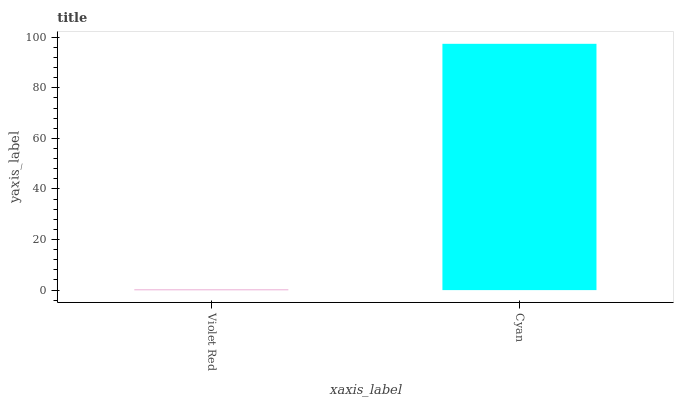Is Violet Red the minimum?
Answer yes or no. Yes. Is Cyan the maximum?
Answer yes or no. Yes. Is Cyan the minimum?
Answer yes or no. No. Is Cyan greater than Violet Red?
Answer yes or no. Yes. Is Violet Red less than Cyan?
Answer yes or no. Yes. Is Violet Red greater than Cyan?
Answer yes or no. No. Is Cyan less than Violet Red?
Answer yes or no. No. Is Cyan the high median?
Answer yes or no. Yes. Is Violet Red the low median?
Answer yes or no. Yes. Is Violet Red the high median?
Answer yes or no. No. Is Cyan the low median?
Answer yes or no. No. 